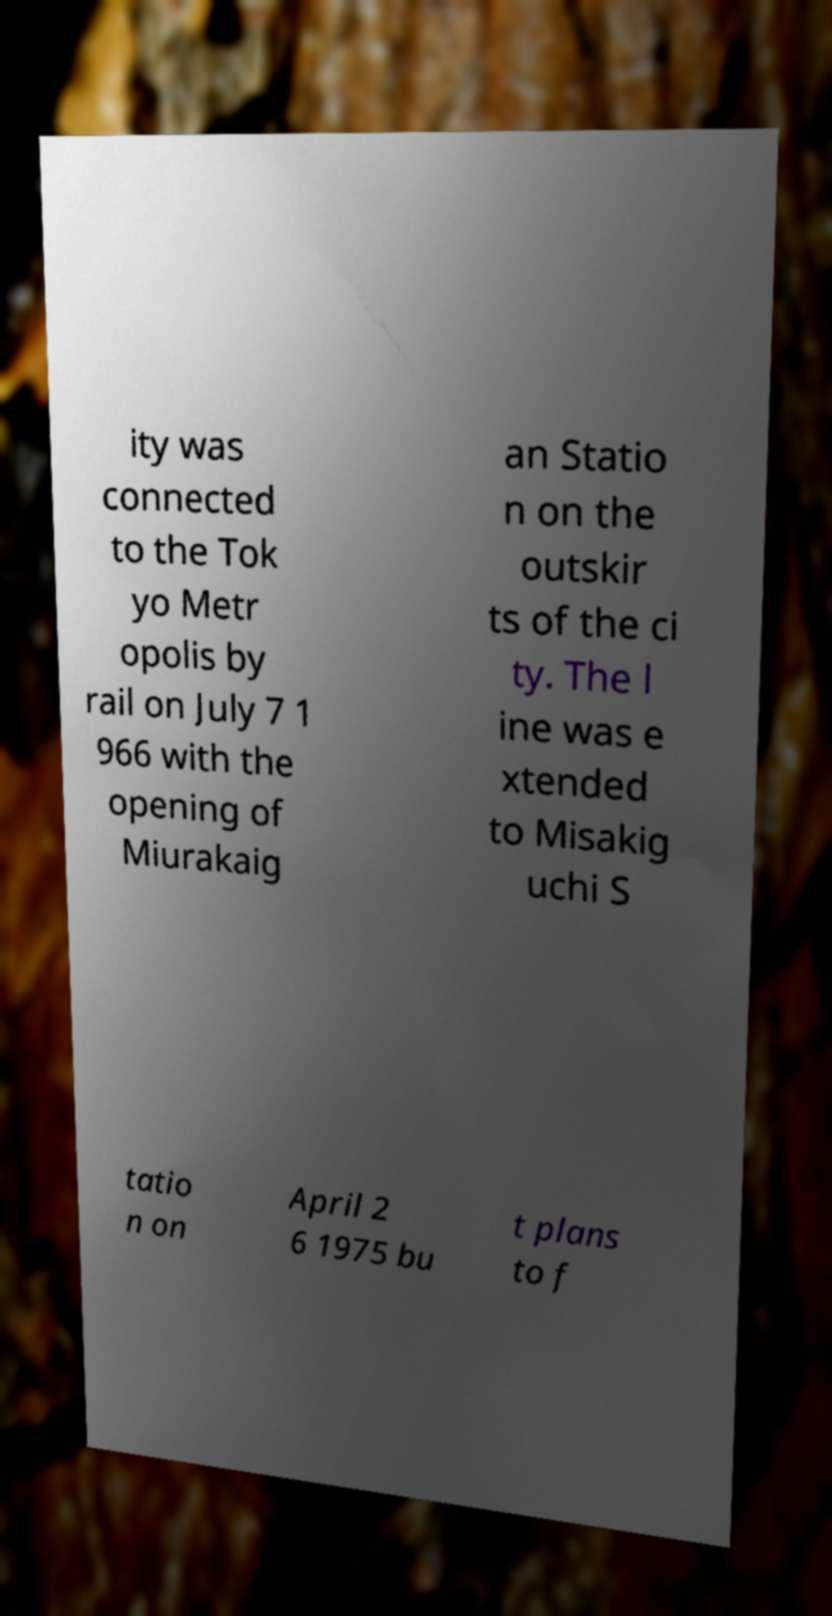Could you extract and type out the text from this image? ity was connected to the Tok yo Metr opolis by rail on July 7 1 966 with the opening of Miurakaig an Statio n on the outskir ts of the ci ty. The l ine was e xtended to Misakig uchi S tatio n on April 2 6 1975 bu t plans to f 